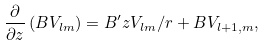<formula> <loc_0><loc_0><loc_500><loc_500>\frac { \partial } { \partial z } \left ( B V _ { l m } \right ) = B ^ { \prime } z V _ { l m } / r + B V _ { l + 1 , m } ,</formula> 